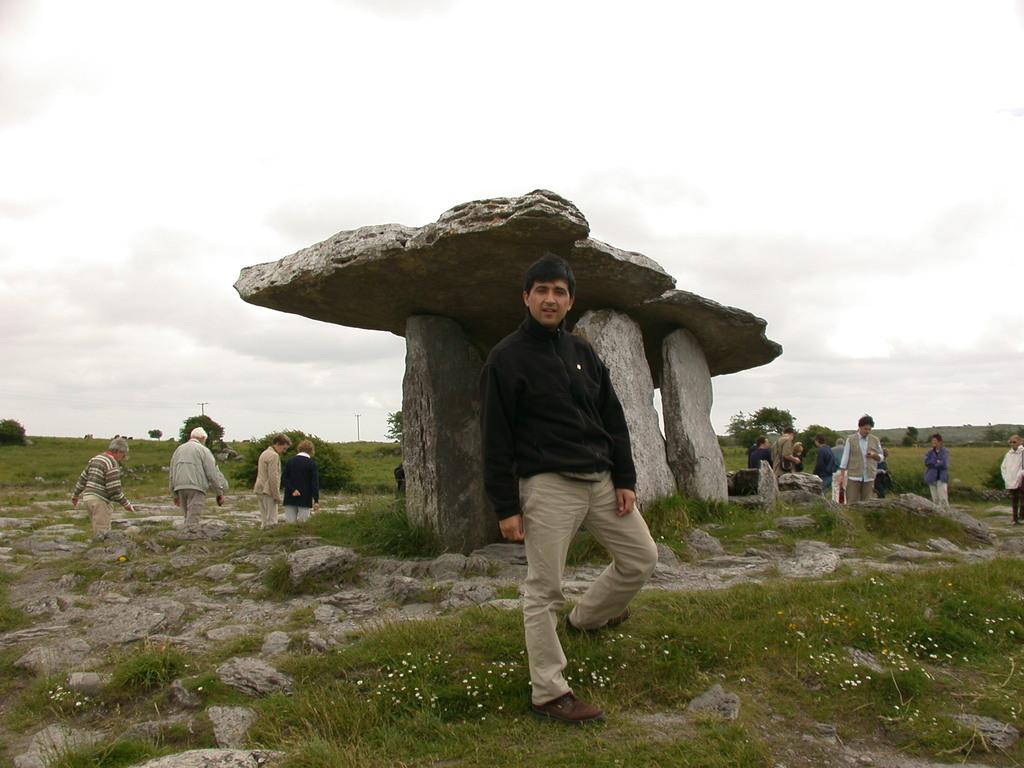What are the people in the image doing? The people in the image are standing around. What type of natural elements can be seen in the image? There are stones, grass, and plants visible in the image. What is the background of the image? The sky is visible in the background of the image. How many dimes are scattered on the ground in the image? There are no dimes present in the image; it features people standing around, stones, grass, plants, and the sky. 